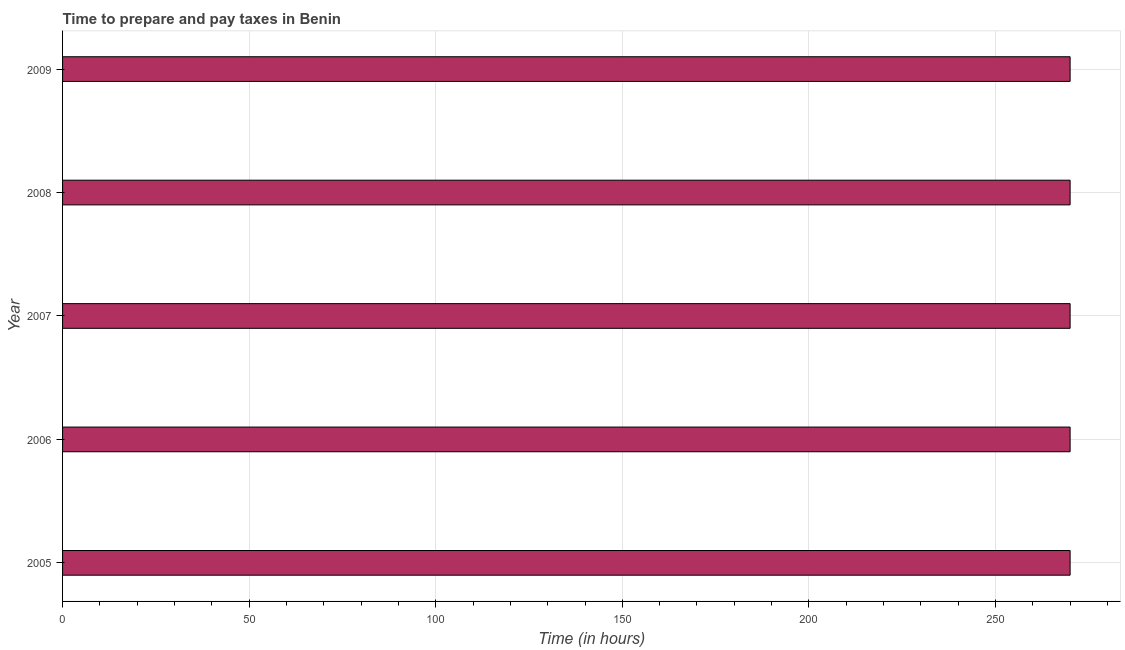Does the graph contain grids?
Your answer should be very brief. Yes. What is the title of the graph?
Your response must be concise. Time to prepare and pay taxes in Benin. What is the label or title of the X-axis?
Provide a succinct answer. Time (in hours). What is the time to prepare and pay taxes in 2006?
Make the answer very short. 270. Across all years, what is the maximum time to prepare and pay taxes?
Make the answer very short. 270. Across all years, what is the minimum time to prepare and pay taxes?
Keep it short and to the point. 270. In which year was the time to prepare and pay taxes maximum?
Give a very brief answer. 2005. In which year was the time to prepare and pay taxes minimum?
Provide a succinct answer. 2005. What is the sum of the time to prepare and pay taxes?
Your response must be concise. 1350. What is the average time to prepare and pay taxes per year?
Ensure brevity in your answer.  270. What is the median time to prepare and pay taxes?
Provide a succinct answer. 270. In how many years, is the time to prepare and pay taxes greater than 50 hours?
Ensure brevity in your answer.  5. Do a majority of the years between 2006 and 2005 (inclusive) have time to prepare and pay taxes greater than 10 hours?
Provide a short and direct response. No. Is the difference between the time to prepare and pay taxes in 2006 and 2008 greater than the difference between any two years?
Make the answer very short. Yes. Is the sum of the time to prepare and pay taxes in 2007 and 2008 greater than the maximum time to prepare and pay taxes across all years?
Give a very brief answer. Yes. In how many years, is the time to prepare and pay taxes greater than the average time to prepare and pay taxes taken over all years?
Provide a succinct answer. 0. How many bars are there?
Provide a short and direct response. 5. What is the difference between two consecutive major ticks on the X-axis?
Your answer should be compact. 50. What is the Time (in hours) of 2005?
Your response must be concise. 270. What is the Time (in hours) in 2006?
Your response must be concise. 270. What is the Time (in hours) of 2007?
Give a very brief answer. 270. What is the Time (in hours) of 2008?
Offer a very short reply. 270. What is the Time (in hours) in 2009?
Keep it short and to the point. 270. What is the difference between the Time (in hours) in 2005 and 2006?
Your answer should be compact. 0. What is the difference between the Time (in hours) in 2006 and 2008?
Give a very brief answer. 0. What is the difference between the Time (in hours) in 2007 and 2009?
Ensure brevity in your answer.  0. What is the ratio of the Time (in hours) in 2005 to that in 2006?
Provide a succinct answer. 1. What is the ratio of the Time (in hours) in 2006 to that in 2007?
Offer a terse response. 1. What is the ratio of the Time (in hours) in 2007 to that in 2008?
Offer a terse response. 1. What is the ratio of the Time (in hours) in 2007 to that in 2009?
Make the answer very short. 1. 